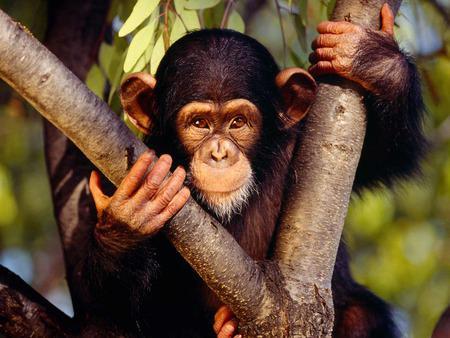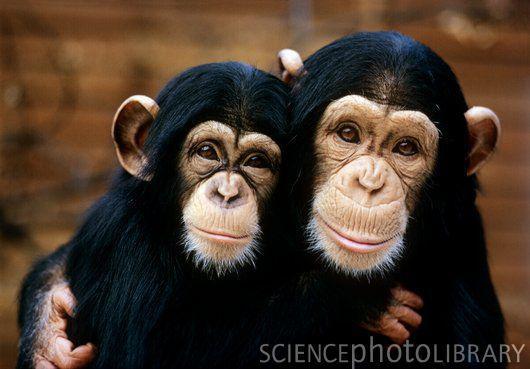The first image is the image on the left, the second image is the image on the right. For the images shown, is this caption "In one image of each pair two chimpanzees are hugging." true? Answer yes or no. Yes. 